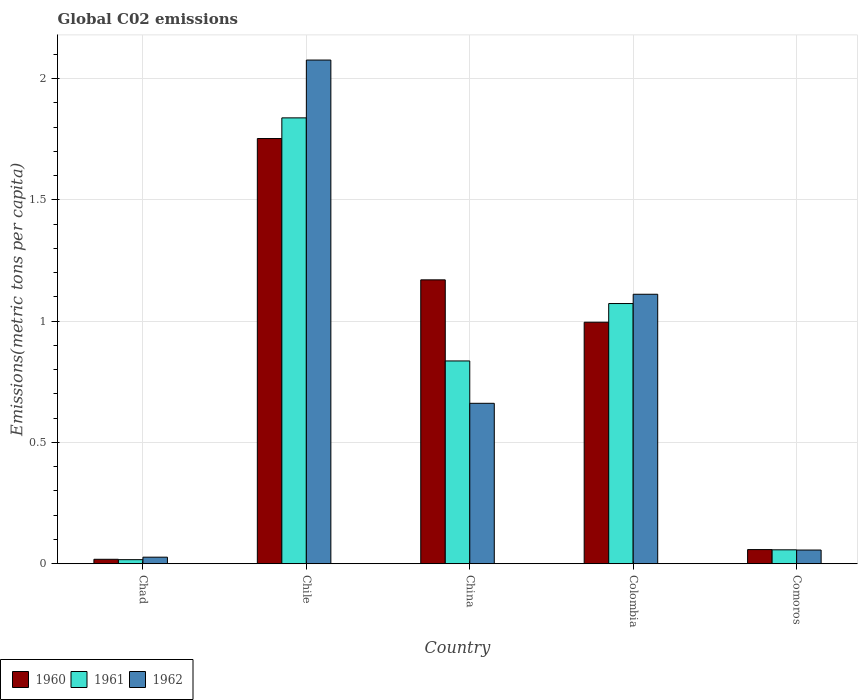How many groups of bars are there?
Provide a short and direct response. 5. What is the label of the 4th group of bars from the left?
Your response must be concise. Colombia. What is the amount of CO2 emitted in in 1962 in Colombia?
Offer a terse response. 1.11. Across all countries, what is the maximum amount of CO2 emitted in in 1961?
Offer a terse response. 1.84. Across all countries, what is the minimum amount of CO2 emitted in in 1962?
Provide a succinct answer. 0.03. In which country was the amount of CO2 emitted in in 1960 maximum?
Provide a short and direct response. Chile. In which country was the amount of CO2 emitted in in 1962 minimum?
Provide a succinct answer. Chad. What is the total amount of CO2 emitted in in 1961 in the graph?
Provide a succinct answer. 3.82. What is the difference between the amount of CO2 emitted in in 1960 in China and that in Comoros?
Provide a short and direct response. 1.11. What is the difference between the amount of CO2 emitted in in 1960 in China and the amount of CO2 emitted in in 1962 in Chile?
Provide a succinct answer. -0.91. What is the average amount of CO2 emitted in in 1962 per country?
Offer a terse response. 0.79. What is the difference between the amount of CO2 emitted in of/in 1961 and amount of CO2 emitted in of/in 1962 in Colombia?
Give a very brief answer. -0.04. In how many countries, is the amount of CO2 emitted in in 1961 greater than 0.8 metric tons per capita?
Your answer should be compact. 3. What is the ratio of the amount of CO2 emitted in in 1960 in Chad to that in Comoros?
Make the answer very short. 0.31. What is the difference between the highest and the second highest amount of CO2 emitted in in 1961?
Offer a very short reply. -1. What is the difference between the highest and the lowest amount of CO2 emitted in in 1962?
Offer a very short reply. 2.05. In how many countries, is the amount of CO2 emitted in in 1961 greater than the average amount of CO2 emitted in in 1961 taken over all countries?
Give a very brief answer. 3. Is the sum of the amount of CO2 emitted in in 1961 in Chad and Chile greater than the maximum amount of CO2 emitted in in 1960 across all countries?
Keep it short and to the point. Yes. What does the 3rd bar from the left in Comoros represents?
Offer a terse response. 1962. Are all the bars in the graph horizontal?
Your answer should be very brief. No. How many countries are there in the graph?
Your response must be concise. 5. Does the graph contain any zero values?
Provide a short and direct response. No. How many legend labels are there?
Make the answer very short. 3. What is the title of the graph?
Offer a very short reply. Global C02 emissions. What is the label or title of the Y-axis?
Provide a succinct answer. Emissions(metric tons per capita). What is the Emissions(metric tons per capita) of 1960 in Chad?
Make the answer very short. 0.02. What is the Emissions(metric tons per capita) in 1961 in Chad?
Make the answer very short. 0.02. What is the Emissions(metric tons per capita) in 1962 in Chad?
Provide a succinct answer. 0.03. What is the Emissions(metric tons per capita) in 1960 in Chile?
Offer a very short reply. 1.75. What is the Emissions(metric tons per capita) in 1961 in Chile?
Your answer should be compact. 1.84. What is the Emissions(metric tons per capita) in 1962 in Chile?
Your response must be concise. 2.08. What is the Emissions(metric tons per capita) in 1960 in China?
Provide a short and direct response. 1.17. What is the Emissions(metric tons per capita) in 1961 in China?
Ensure brevity in your answer.  0.84. What is the Emissions(metric tons per capita) in 1962 in China?
Your answer should be very brief. 0.66. What is the Emissions(metric tons per capita) of 1960 in Colombia?
Offer a very short reply. 1. What is the Emissions(metric tons per capita) of 1961 in Colombia?
Your answer should be compact. 1.07. What is the Emissions(metric tons per capita) of 1962 in Colombia?
Give a very brief answer. 1.11. What is the Emissions(metric tons per capita) in 1960 in Comoros?
Your answer should be compact. 0.06. What is the Emissions(metric tons per capita) of 1961 in Comoros?
Provide a succinct answer. 0.06. What is the Emissions(metric tons per capita) in 1962 in Comoros?
Your answer should be very brief. 0.06. Across all countries, what is the maximum Emissions(metric tons per capita) in 1960?
Ensure brevity in your answer.  1.75. Across all countries, what is the maximum Emissions(metric tons per capita) of 1961?
Your answer should be very brief. 1.84. Across all countries, what is the maximum Emissions(metric tons per capita) in 1962?
Ensure brevity in your answer.  2.08. Across all countries, what is the minimum Emissions(metric tons per capita) of 1960?
Make the answer very short. 0.02. Across all countries, what is the minimum Emissions(metric tons per capita) of 1961?
Make the answer very short. 0.02. Across all countries, what is the minimum Emissions(metric tons per capita) in 1962?
Your answer should be very brief. 0.03. What is the total Emissions(metric tons per capita) of 1960 in the graph?
Keep it short and to the point. 4. What is the total Emissions(metric tons per capita) of 1961 in the graph?
Your answer should be very brief. 3.82. What is the total Emissions(metric tons per capita) of 1962 in the graph?
Provide a short and direct response. 3.93. What is the difference between the Emissions(metric tons per capita) of 1960 in Chad and that in Chile?
Keep it short and to the point. -1.73. What is the difference between the Emissions(metric tons per capita) of 1961 in Chad and that in Chile?
Offer a terse response. -1.82. What is the difference between the Emissions(metric tons per capita) of 1962 in Chad and that in Chile?
Provide a succinct answer. -2.05. What is the difference between the Emissions(metric tons per capita) in 1960 in Chad and that in China?
Your response must be concise. -1.15. What is the difference between the Emissions(metric tons per capita) of 1961 in Chad and that in China?
Provide a succinct answer. -0.82. What is the difference between the Emissions(metric tons per capita) in 1962 in Chad and that in China?
Give a very brief answer. -0.63. What is the difference between the Emissions(metric tons per capita) of 1960 in Chad and that in Colombia?
Ensure brevity in your answer.  -0.98. What is the difference between the Emissions(metric tons per capita) in 1961 in Chad and that in Colombia?
Provide a short and direct response. -1.06. What is the difference between the Emissions(metric tons per capita) of 1962 in Chad and that in Colombia?
Your answer should be very brief. -1.08. What is the difference between the Emissions(metric tons per capita) of 1960 in Chad and that in Comoros?
Keep it short and to the point. -0.04. What is the difference between the Emissions(metric tons per capita) of 1961 in Chad and that in Comoros?
Your answer should be very brief. -0.04. What is the difference between the Emissions(metric tons per capita) of 1962 in Chad and that in Comoros?
Your answer should be compact. -0.03. What is the difference between the Emissions(metric tons per capita) in 1960 in Chile and that in China?
Provide a succinct answer. 0.58. What is the difference between the Emissions(metric tons per capita) of 1961 in Chile and that in China?
Your response must be concise. 1. What is the difference between the Emissions(metric tons per capita) of 1962 in Chile and that in China?
Offer a terse response. 1.42. What is the difference between the Emissions(metric tons per capita) of 1960 in Chile and that in Colombia?
Provide a short and direct response. 0.76. What is the difference between the Emissions(metric tons per capita) of 1961 in Chile and that in Colombia?
Offer a terse response. 0.77. What is the difference between the Emissions(metric tons per capita) of 1962 in Chile and that in Colombia?
Ensure brevity in your answer.  0.97. What is the difference between the Emissions(metric tons per capita) of 1960 in Chile and that in Comoros?
Keep it short and to the point. 1.69. What is the difference between the Emissions(metric tons per capita) of 1961 in Chile and that in Comoros?
Keep it short and to the point. 1.78. What is the difference between the Emissions(metric tons per capita) in 1962 in Chile and that in Comoros?
Your response must be concise. 2.02. What is the difference between the Emissions(metric tons per capita) in 1960 in China and that in Colombia?
Your answer should be compact. 0.17. What is the difference between the Emissions(metric tons per capita) in 1961 in China and that in Colombia?
Offer a terse response. -0.24. What is the difference between the Emissions(metric tons per capita) of 1962 in China and that in Colombia?
Make the answer very short. -0.45. What is the difference between the Emissions(metric tons per capita) of 1960 in China and that in Comoros?
Ensure brevity in your answer.  1.11. What is the difference between the Emissions(metric tons per capita) of 1961 in China and that in Comoros?
Keep it short and to the point. 0.78. What is the difference between the Emissions(metric tons per capita) of 1962 in China and that in Comoros?
Make the answer very short. 0.6. What is the difference between the Emissions(metric tons per capita) of 1960 in Colombia and that in Comoros?
Offer a very short reply. 0.94. What is the difference between the Emissions(metric tons per capita) of 1961 in Colombia and that in Comoros?
Your answer should be very brief. 1.02. What is the difference between the Emissions(metric tons per capita) in 1962 in Colombia and that in Comoros?
Your answer should be very brief. 1.05. What is the difference between the Emissions(metric tons per capita) of 1960 in Chad and the Emissions(metric tons per capita) of 1961 in Chile?
Provide a short and direct response. -1.82. What is the difference between the Emissions(metric tons per capita) of 1960 in Chad and the Emissions(metric tons per capita) of 1962 in Chile?
Provide a short and direct response. -2.06. What is the difference between the Emissions(metric tons per capita) of 1961 in Chad and the Emissions(metric tons per capita) of 1962 in Chile?
Ensure brevity in your answer.  -2.06. What is the difference between the Emissions(metric tons per capita) in 1960 in Chad and the Emissions(metric tons per capita) in 1961 in China?
Provide a short and direct response. -0.82. What is the difference between the Emissions(metric tons per capita) in 1960 in Chad and the Emissions(metric tons per capita) in 1962 in China?
Provide a short and direct response. -0.64. What is the difference between the Emissions(metric tons per capita) in 1961 in Chad and the Emissions(metric tons per capita) in 1962 in China?
Make the answer very short. -0.64. What is the difference between the Emissions(metric tons per capita) in 1960 in Chad and the Emissions(metric tons per capita) in 1961 in Colombia?
Provide a succinct answer. -1.05. What is the difference between the Emissions(metric tons per capita) in 1960 in Chad and the Emissions(metric tons per capita) in 1962 in Colombia?
Make the answer very short. -1.09. What is the difference between the Emissions(metric tons per capita) of 1961 in Chad and the Emissions(metric tons per capita) of 1962 in Colombia?
Offer a very short reply. -1.09. What is the difference between the Emissions(metric tons per capita) of 1960 in Chad and the Emissions(metric tons per capita) of 1961 in Comoros?
Ensure brevity in your answer.  -0.04. What is the difference between the Emissions(metric tons per capita) in 1960 in Chad and the Emissions(metric tons per capita) in 1962 in Comoros?
Make the answer very short. -0.04. What is the difference between the Emissions(metric tons per capita) of 1961 in Chad and the Emissions(metric tons per capita) of 1962 in Comoros?
Provide a short and direct response. -0.04. What is the difference between the Emissions(metric tons per capita) in 1960 in Chile and the Emissions(metric tons per capita) in 1961 in China?
Keep it short and to the point. 0.92. What is the difference between the Emissions(metric tons per capita) of 1960 in Chile and the Emissions(metric tons per capita) of 1962 in China?
Your answer should be compact. 1.09. What is the difference between the Emissions(metric tons per capita) of 1961 in Chile and the Emissions(metric tons per capita) of 1962 in China?
Your response must be concise. 1.18. What is the difference between the Emissions(metric tons per capita) of 1960 in Chile and the Emissions(metric tons per capita) of 1961 in Colombia?
Provide a short and direct response. 0.68. What is the difference between the Emissions(metric tons per capita) in 1960 in Chile and the Emissions(metric tons per capita) in 1962 in Colombia?
Ensure brevity in your answer.  0.64. What is the difference between the Emissions(metric tons per capita) in 1961 in Chile and the Emissions(metric tons per capita) in 1962 in Colombia?
Keep it short and to the point. 0.73. What is the difference between the Emissions(metric tons per capita) in 1960 in Chile and the Emissions(metric tons per capita) in 1961 in Comoros?
Provide a succinct answer. 1.7. What is the difference between the Emissions(metric tons per capita) of 1960 in Chile and the Emissions(metric tons per capita) of 1962 in Comoros?
Your response must be concise. 1.7. What is the difference between the Emissions(metric tons per capita) in 1961 in Chile and the Emissions(metric tons per capita) in 1962 in Comoros?
Your answer should be compact. 1.78. What is the difference between the Emissions(metric tons per capita) of 1960 in China and the Emissions(metric tons per capita) of 1961 in Colombia?
Give a very brief answer. 0.1. What is the difference between the Emissions(metric tons per capita) of 1960 in China and the Emissions(metric tons per capita) of 1962 in Colombia?
Make the answer very short. 0.06. What is the difference between the Emissions(metric tons per capita) in 1961 in China and the Emissions(metric tons per capita) in 1962 in Colombia?
Your answer should be very brief. -0.27. What is the difference between the Emissions(metric tons per capita) in 1960 in China and the Emissions(metric tons per capita) in 1961 in Comoros?
Ensure brevity in your answer.  1.11. What is the difference between the Emissions(metric tons per capita) of 1960 in China and the Emissions(metric tons per capita) of 1962 in Comoros?
Ensure brevity in your answer.  1.11. What is the difference between the Emissions(metric tons per capita) in 1961 in China and the Emissions(metric tons per capita) in 1962 in Comoros?
Keep it short and to the point. 0.78. What is the difference between the Emissions(metric tons per capita) in 1960 in Colombia and the Emissions(metric tons per capita) in 1961 in Comoros?
Your answer should be compact. 0.94. What is the difference between the Emissions(metric tons per capita) of 1960 in Colombia and the Emissions(metric tons per capita) of 1962 in Comoros?
Your answer should be very brief. 0.94. What is the difference between the Emissions(metric tons per capita) of 1961 in Colombia and the Emissions(metric tons per capita) of 1962 in Comoros?
Make the answer very short. 1.02. What is the average Emissions(metric tons per capita) of 1960 per country?
Keep it short and to the point. 0.8. What is the average Emissions(metric tons per capita) in 1961 per country?
Your response must be concise. 0.76. What is the average Emissions(metric tons per capita) in 1962 per country?
Keep it short and to the point. 0.79. What is the difference between the Emissions(metric tons per capita) in 1960 and Emissions(metric tons per capita) in 1961 in Chad?
Offer a very short reply. 0. What is the difference between the Emissions(metric tons per capita) in 1960 and Emissions(metric tons per capita) in 1962 in Chad?
Make the answer very short. -0.01. What is the difference between the Emissions(metric tons per capita) in 1961 and Emissions(metric tons per capita) in 1962 in Chad?
Ensure brevity in your answer.  -0.01. What is the difference between the Emissions(metric tons per capita) of 1960 and Emissions(metric tons per capita) of 1961 in Chile?
Make the answer very short. -0.09. What is the difference between the Emissions(metric tons per capita) in 1960 and Emissions(metric tons per capita) in 1962 in Chile?
Provide a succinct answer. -0.32. What is the difference between the Emissions(metric tons per capita) in 1961 and Emissions(metric tons per capita) in 1962 in Chile?
Your answer should be compact. -0.24. What is the difference between the Emissions(metric tons per capita) of 1960 and Emissions(metric tons per capita) of 1961 in China?
Your response must be concise. 0.33. What is the difference between the Emissions(metric tons per capita) in 1960 and Emissions(metric tons per capita) in 1962 in China?
Provide a short and direct response. 0.51. What is the difference between the Emissions(metric tons per capita) of 1961 and Emissions(metric tons per capita) of 1962 in China?
Your answer should be compact. 0.17. What is the difference between the Emissions(metric tons per capita) in 1960 and Emissions(metric tons per capita) in 1961 in Colombia?
Your answer should be very brief. -0.08. What is the difference between the Emissions(metric tons per capita) of 1960 and Emissions(metric tons per capita) of 1962 in Colombia?
Keep it short and to the point. -0.12. What is the difference between the Emissions(metric tons per capita) in 1961 and Emissions(metric tons per capita) in 1962 in Colombia?
Keep it short and to the point. -0.04. What is the difference between the Emissions(metric tons per capita) of 1960 and Emissions(metric tons per capita) of 1961 in Comoros?
Keep it short and to the point. 0. What is the difference between the Emissions(metric tons per capita) of 1960 and Emissions(metric tons per capita) of 1962 in Comoros?
Your response must be concise. 0. What is the difference between the Emissions(metric tons per capita) in 1961 and Emissions(metric tons per capita) in 1962 in Comoros?
Your answer should be very brief. 0. What is the ratio of the Emissions(metric tons per capita) in 1960 in Chad to that in Chile?
Make the answer very short. 0.01. What is the ratio of the Emissions(metric tons per capita) of 1961 in Chad to that in Chile?
Keep it short and to the point. 0.01. What is the ratio of the Emissions(metric tons per capita) of 1962 in Chad to that in Chile?
Provide a succinct answer. 0.01. What is the ratio of the Emissions(metric tons per capita) of 1960 in Chad to that in China?
Make the answer very short. 0.02. What is the ratio of the Emissions(metric tons per capita) in 1961 in Chad to that in China?
Your answer should be compact. 0.02. What is the ratio of the Emissions(metric tons per capita) of 1962 in Chad to that in China?
Your answer should be very brief. 0.04. What is the ratio of the Emissions(metric tons per capita) of 1960 in Chad to that in Colombia?
Provide a short and direct response. 0.02. What is the ratio of the Emissions(metric tons per capita) in 1961 in Chad to that in Colombia?
Your response must be concise. 0.02. What is the ratio of the Emissions(metric tons per capita) in 1962 in Chad to that in Colombia?
Provide a succinct answer. 0.02. What is the ratio of the Emissions(metric tons per capita) in 1960 in Chad to that in Comoros?
Provide a succinct answer. 0.31. What is the ratio of the Emissions(metric tons per capita) in 1961 in Chad to that in Comoros?
Provide a succinct answer. 0.29. What is the ratio of the Emissions(metric tons per capita) of 1962 in Chad to that in Comoros?
Your answer should be compact. 0.48. What is the ratio of the Emissions(metric tons per capita) of 1960 in Chile to that in China?
Offer a terse response. 1.5. What is the ratio of the Emissions(metric tons per capita) in 1961 in Chile to that in China?
Offer a very short reply. 2.2. What is the ratio of the Emissions(metric tons per capita) of 1962 in Chile to that in China?
Your answer should be very brief. 3.14. What is the ratio of the Emissions(metric tons per capita) of 1960 in Chile to that in Colombia?
Give a very brief answer. 1.76. What is the ratio of the Emissions(metric tons per capita) of 1961 in Chile to that in Colombia?
Ensure brevity in your answer.  1.71. What is the ratio of the Emissions(metric tons per capita) of 1962 in Chile to that in Colombia?
Keep it short and to the point. 1.87. What is the ratio of the Emissions(metric tons per capita) of 1960 in Chile to that in Comoros?
Offer a terse response. 30.08. What is the ratio of the Emissions(metric tons per capita) in 1961 in Chile to that in Comoros?
Your response must be concise. 32.05. What is the ratio of the Emissions(metric tons per capita) in 1962 in Chile to that in Comoros?
Ensure brevity in your answer.  36.8. What is the ratio of the Emissions(metric tons per capita) in 1960 in China to that in Colombia?
Give a very brief answer. 1.18. What is the ratio of the Emissions(metric tons per capita) of 1961 in China to that in Colombia?
Your answer should be very brief. 0.78. What is the ratio of the Emissions(metric tons per capita) of 1962 in China to that in Colombia?
Offer a very short reply. 0.6. What is the ratio of the Emissions(metric tons per capita) of 1960 in China to that in Comoros?
Your response must be concise. 20.08. What is the ratio of the Emissions(metric tons per capita) of 1961 in China to that in Comoros?
Provide a short and direct response. 14.58. What is the ratio of the Emissions(metric tons per capita) in 1962 in China to that in Comoros?
Give a very brief answer. 11.72. What is the ratio of the Emissions(metric tons per capita) in 1960 in Colombia to that in Comoros?
Your response must be concise. 17.08. What is the ratio of the Emissions(metric tons per capita) in 1961 in Colombia to that in Comoros?
Provide a short and direct response. 18.71. What is the ratio of the Emissions(metric tons per capita) of 1962 in Colombia to that in Comoros?
Make the answer very short. 19.69. What is the difference between the highest and the second highest Emissions(metric tons per capita) in 1960?
Your answer should be compact. 0.58. What is the difference between the highest and the second highest Emissions(metric tons per capita) of 1961?
Offer a terse response. 0.77. What is the difference between the highest and the second highest Emissions(metric tons per capita) of 1962?
Give a very brief answer. 0.97. What is the difference between the highest and the lowest Emissions(metric tons per capita) of 1960?
Your answer should be compact. 1.73. What is the difference between the highest and the lowest Emissions(metric tons per capita) in 1961?
Give a very brief answer. 1.82. What is the difference between the highest and the lowest Emissions(metric tons per capita) of 1962?
Your answer should be compact. 2.05. 